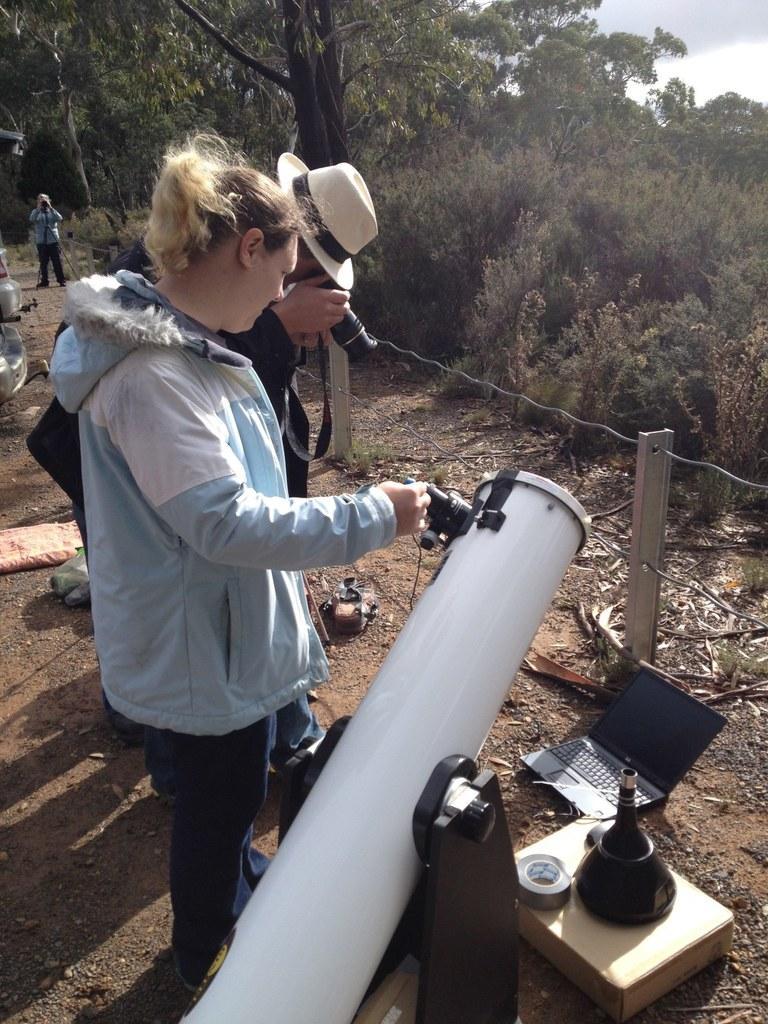How would you summarize this image in a sentence or two? In this image I can see three persons are standing on the ground. I can see one person is holding a camera and I can also see one of them is wearing a hat. In the front of the image I can see a telescope, a laptop and few other things on the ground. On the right side of the image I can see two poles, two wires, number of trees, clouds and the sky. 